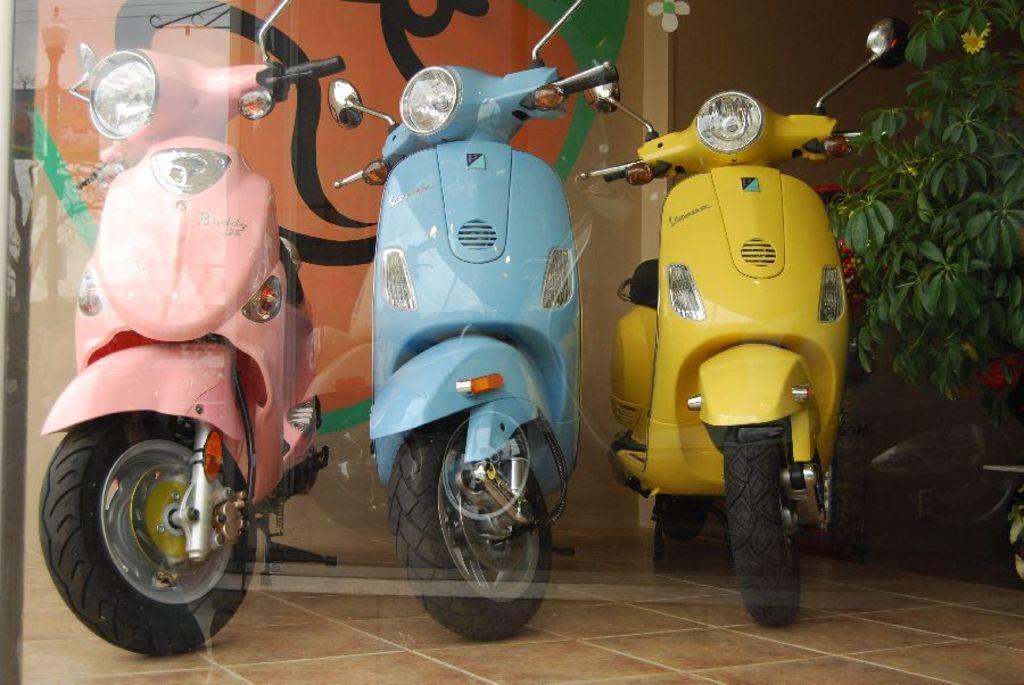How would you summarize this image in a sentence or two? In this image I can see three vehicles, they are in pink, blue and yellow color. Background I can see plants in green color and I can see a multi color wall. 